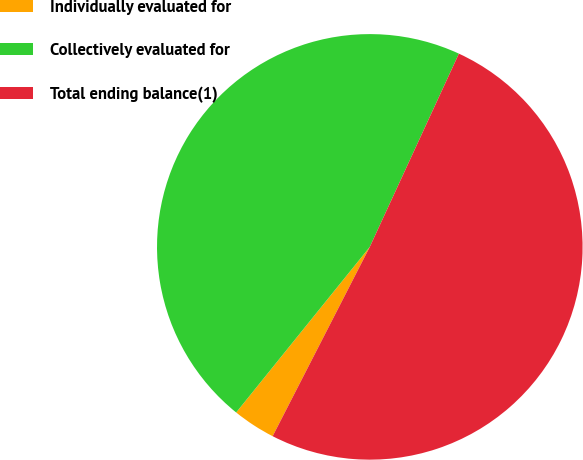Convert chart. <chart><loc_0><loc_0><loc_500><loc_500><pie_chart><fcel>Individually evaluated for<fcel>Collectively evaluated for<fcel>Total ending balance(1)<nl><fcel>3.26%<fcel>46.07%<fcel>50.67%<nl></chart> 